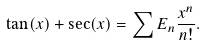Convert formula to latex. <formula><loc_0><loc_0><loc_500><loc_500>\tan ( x ) + \sec ( x ) = \sum E _ { n } \frac { x ^ { n } } { n ! } .</formula> 